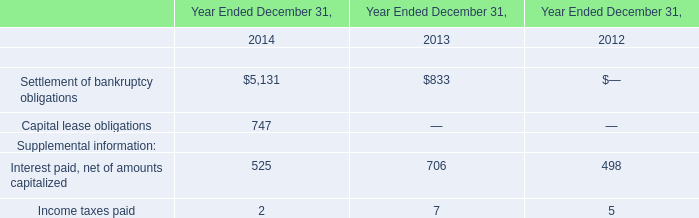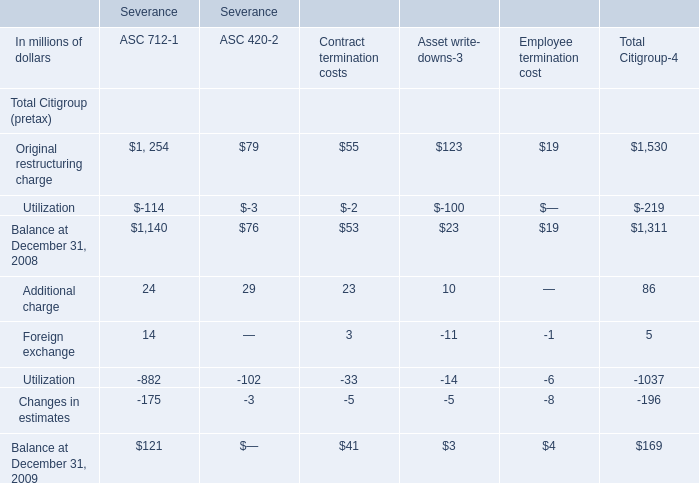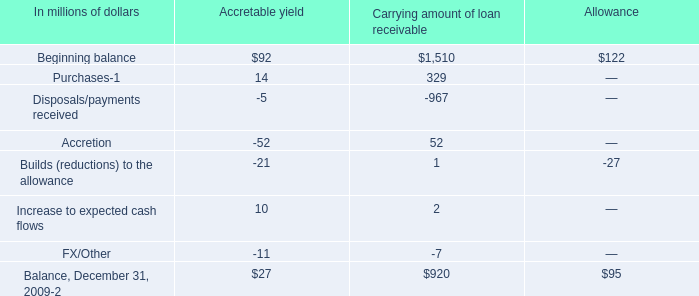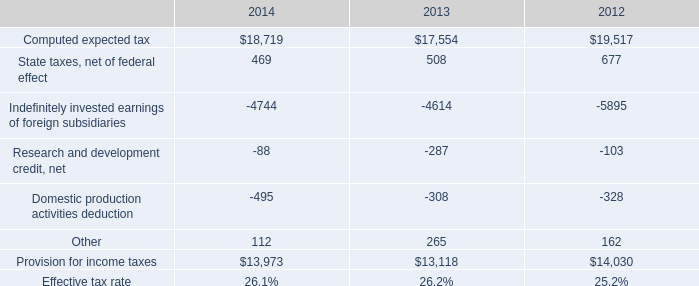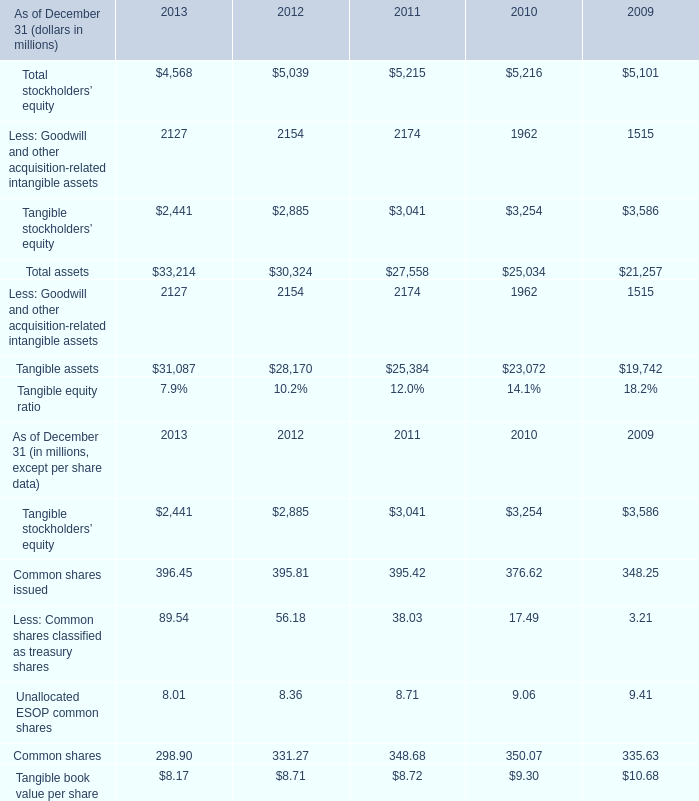What is the total value of Changes in estimates, Utilization, Foreign exchange and Additional charge in in 2009 for ASC 712-1? (in million) 
Computations: (((24 + 14) - 882) - 175)
Answer: -1019.0. 